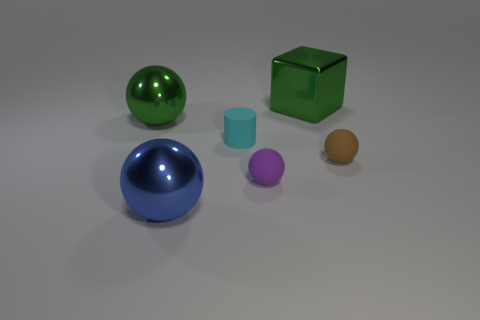How many things are either green shiny things or small purple matte objects?
Your answer should be very brief. 3. What shape is the object that is on the left side of the tiny purple thing and in front of the small brown ball?
Your answer should be compact. Sphere. Does the blue shiny thing have the same shape as the tiny thing behind the tiny brown object?
Your response must be concise. No. Are there any balls to the left of the small purple object?
Keep it short and to the point. Yes. There is a big sphere that is the same color as the large block; what is it made of?
Keep it short and to the point. Metal. How many cubes are cyan objects or small purple objects?
Provide a short and direct response. 0. Is the tiny purple object the same shape as the tiny cyan matte thing?
Your answer should be very brief. No. What size is the object on the left side of the large blue shiny thing?
Provide a succinct answer. Large. Are there any metallic spheres of the same color as the large block?
Your answer should be compact. Yes. Is the size of the matte ball to the left of the brown sphere the same as the big metal block?
Your response must be concise. No. 